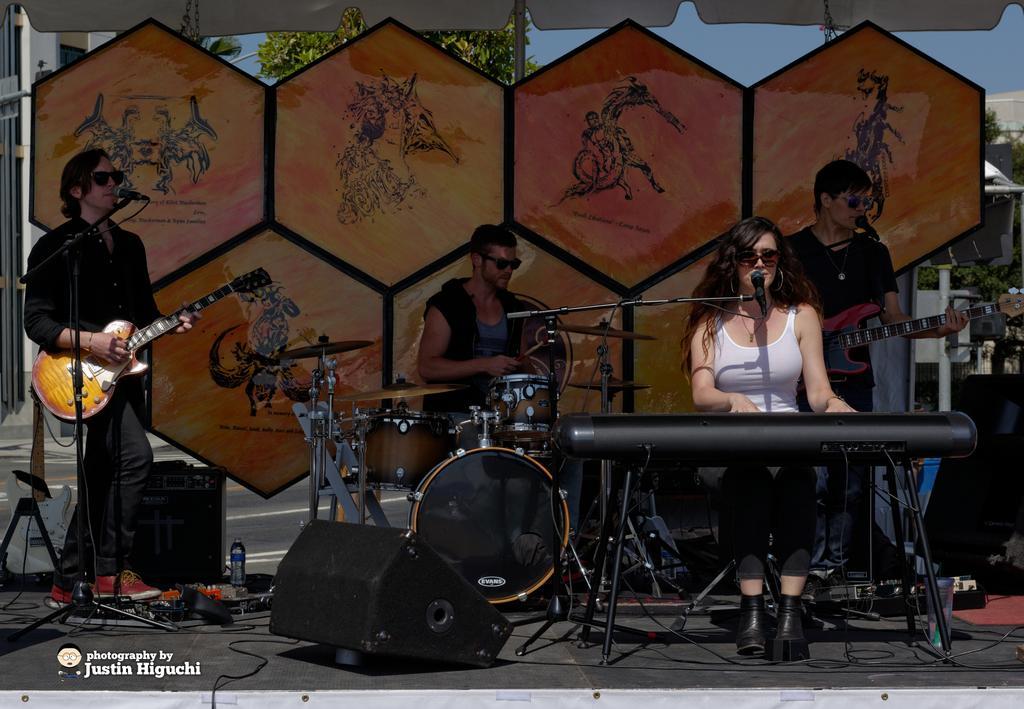Describe this image in one or two sentences. On the background we can see sky, building and trees. Here this is a platform. We can see four persons playing musical instruments and they all wore goggles. Background of the platform is decorated nicely. This is a water bottle. 